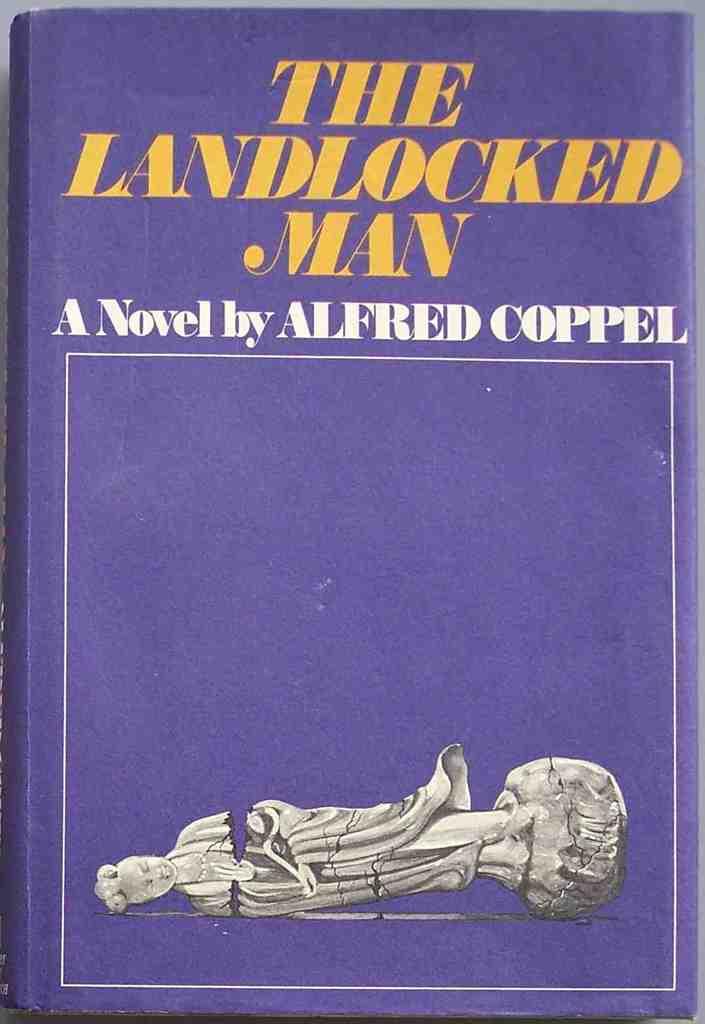What is the name of the author of this novel?
Keep it short and to the point. Alfred coppel. What is the name of the title?
Your answer should be very brief. The landlocked man. 